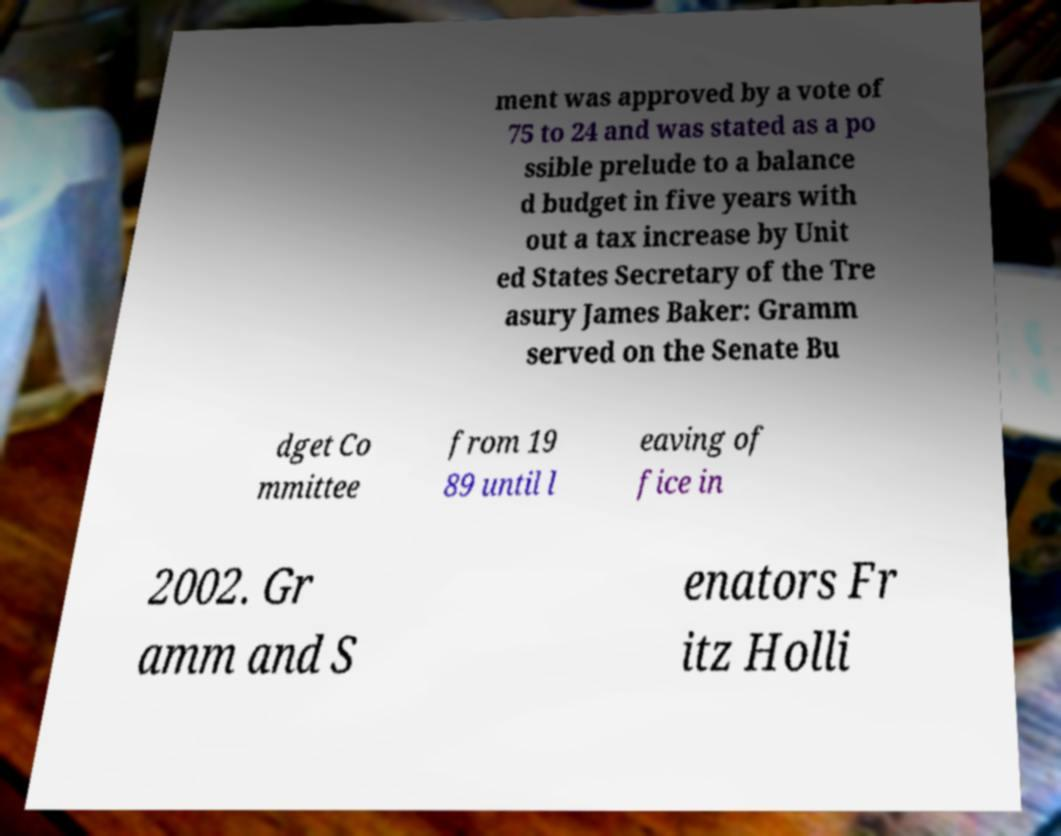What messages or text are displayed in this image? I need them in a readable, typed format. ment was approved by a vote of 75 to 24 and was stated as a po ssible prelude to a balance d budget in five years with out a tax increase by Unit ed States Secretary of the Tre asury James Baker: Gramm served on the Senate Bu dget Co mmittee from 19 89 until l eaving of fice in 2002. Gr amm and S enators Fr itz Holli 